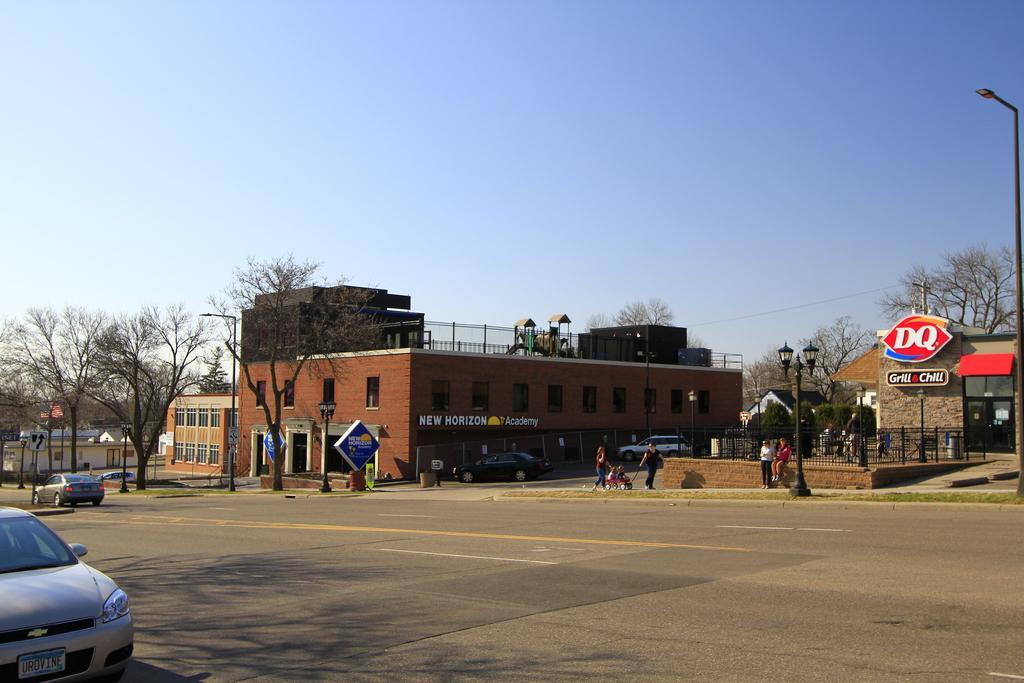In one or two sentences, can you explain what this image depicts? In the foreground of the picture it is road. On the left there is a car. In the center of the picture there are buildings, trees, street light, boards, people, cars and other objects. Sky is sunny. 